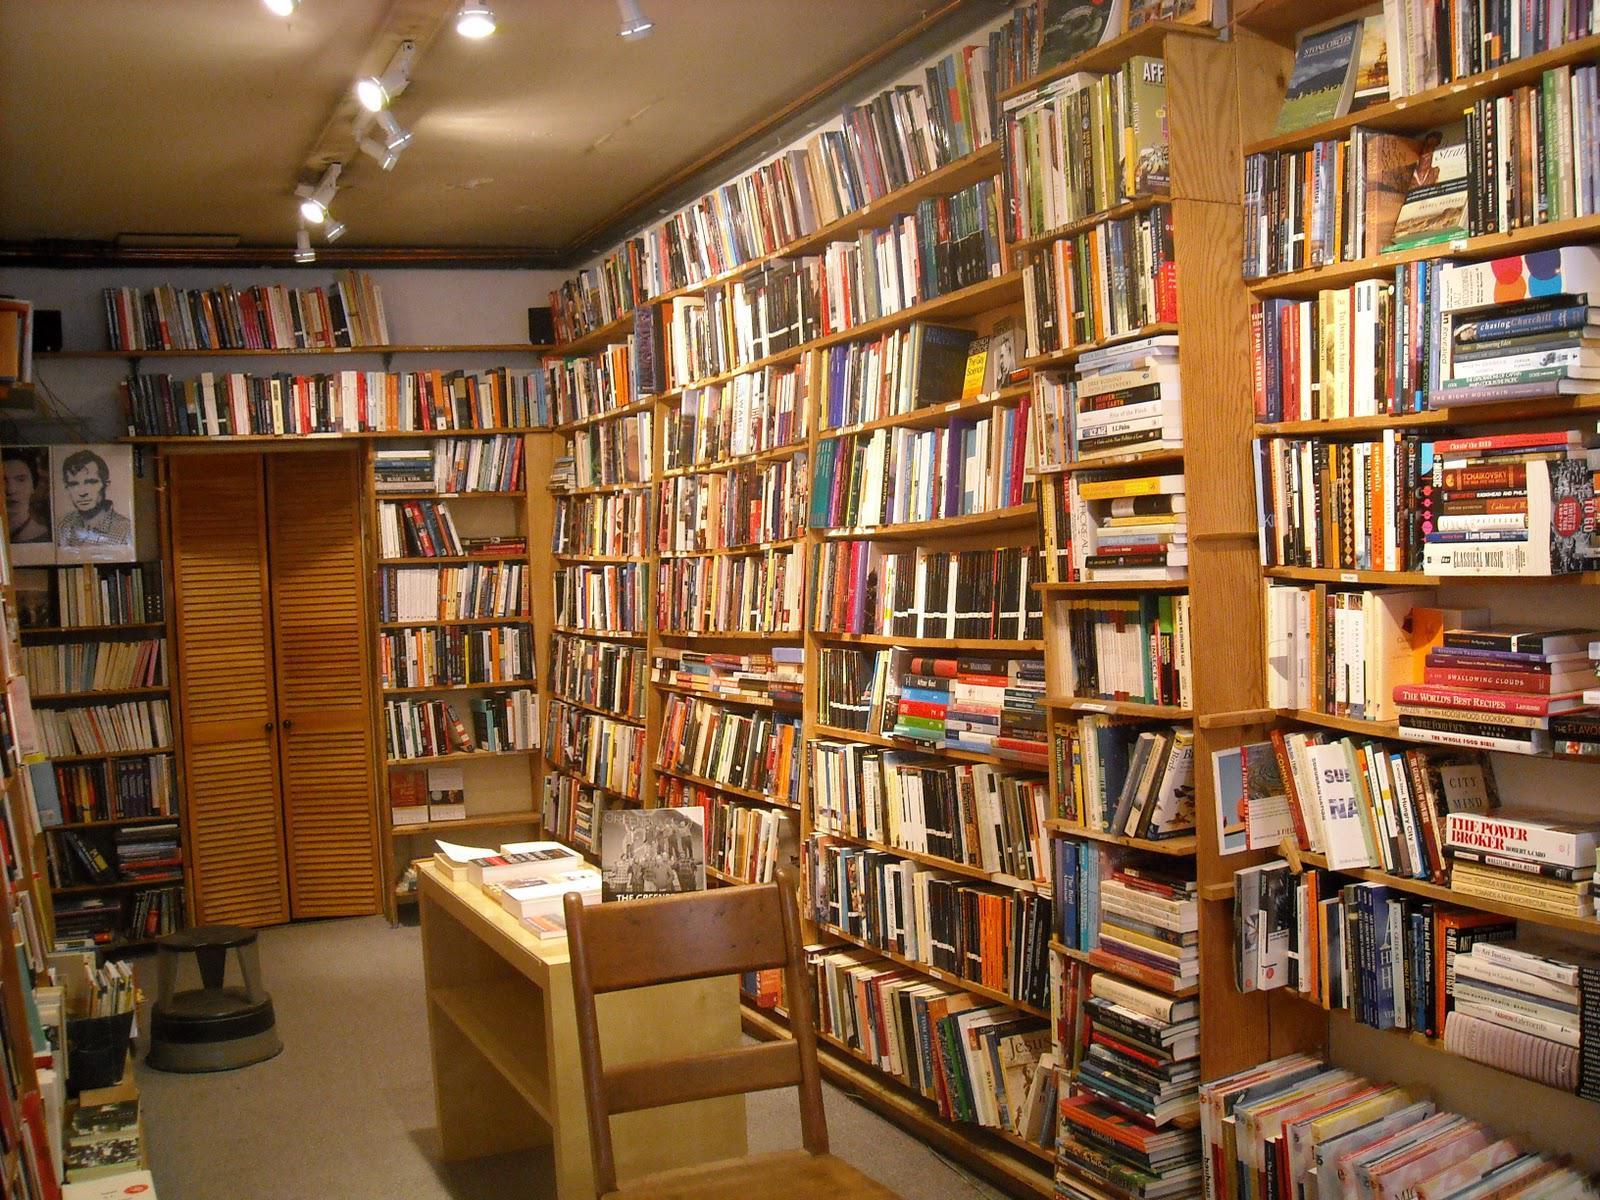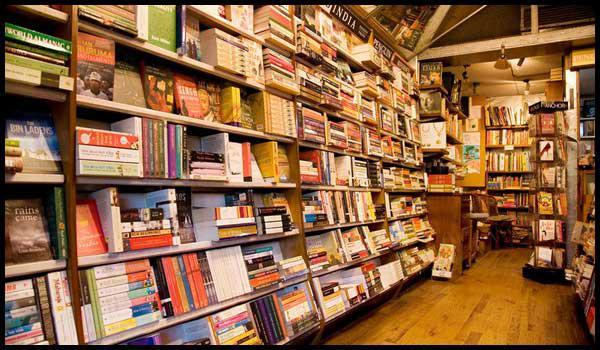The first image is the image on the left, the second image is the image on the right. For the images displayed, is the sentence "In at least one of the images, the source of light is from a track of spotlights on the ceiling." factually correct? Answer yes or no. Yes. 